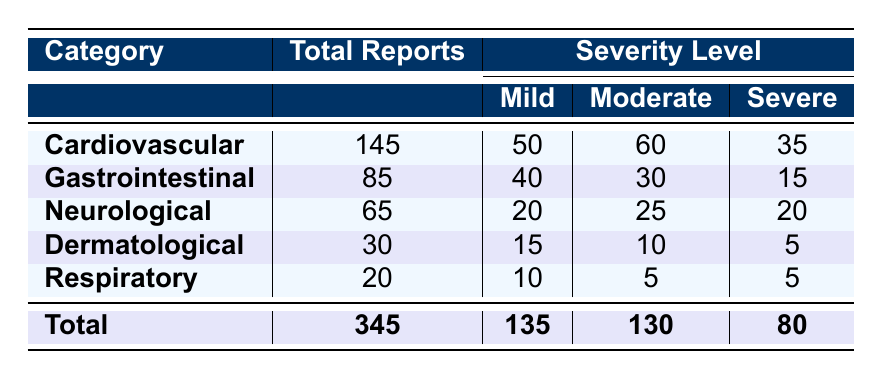What is the total number of adverse reports for Lisinopril? The table provides a total of 345 reports for the drug Lisinopril as indicated in the "Total" row.
Answer: 345 How many reports were categorized under Cardiovascular adverse events? The "Total Reports" for Cardiovascular events is 145 as shown in the relevant row of the table.
Answer: 145 What is the total count of severe adverse events across all categories? To find this, we sum the severe counts from each category: (35 + 15 + 20 + 5 + 5) = 80.
Answer: 80 Which category has the highest number of mild adverse events? Cardiovascular has 50 mild events, which is the highest compared to other categories.
Answer: Cardiovascular What percentage of total reports were classified as moderate adverse events? The moderate reports total 130. To calculate the percentage: (130/345) * 100 ≈ 37.68%.
Answer: Approximately 37.68% Is the number of reports for gastrointestinal adverse events greater than that for respiratory events? The gastrointestinal events have 85 reports and respiratory events have 20 reports, so 85 > 20 is true.
Answer: Yes How many mild adverse events are reported in the Neurological category? The Neurological category shows a total of 20 reports classified as mild.
Answer: 20 What is the total number of mild and severe adverse events combined? To find this, we sum the mild and severe reports: (135 + 80) = 215.
Answer: 215 Which age group reported the most adverse events? The age group 46-60 has the most reports with a count of 100, as indicated by the data section.
Answer: 46-60 If we were to classify the total adverse events into moderate and severe, what proportion do they represent together? The moderate and severe totals are 130 and 80. Together they represent (130 + 80) = 210 out of 345 total events, so the proportion is (210/345) * 100 ≈ 60.87%.
Answer: Approximately 60.87% 